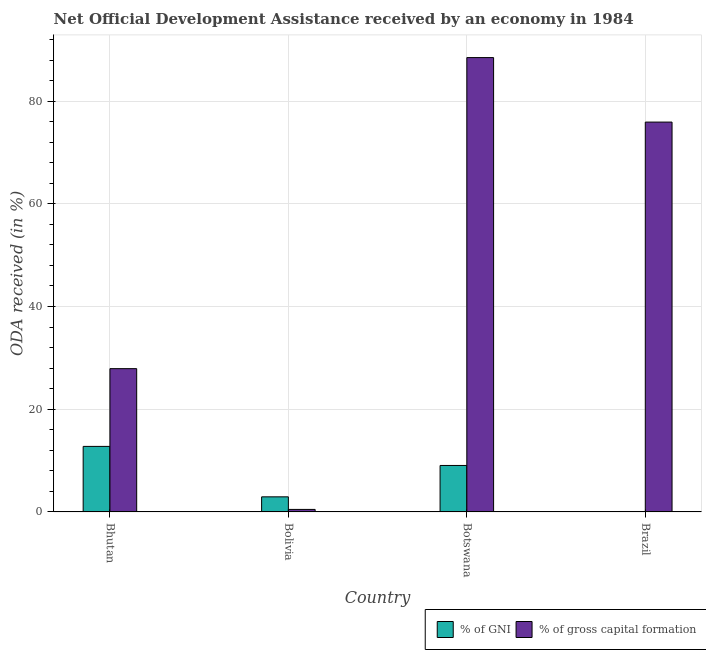How many different coloured bars are there?
Provide a short and direct response. 2. Are the number of bars on each tick of the X-axis equal?
Provide a short and direct response. Yes. How many bars are there on the 4th tick from the left?
Offer a terse response. 2. What is the label of the 3rd group of bars from the left?
Provide a short and direct response. Botswana. What is the oda received as percentage of gross capital formation in Brazil?
Provide a short and direct response. 75.92. Across all countries, what is the maximum oda received as percentage of gni?
Give a very brief answer. 12.76. Across all countries, what is the minimum oda received as percentage of gni?
Make the answer very short. 0.08. In which country was the oda received as percentage of gross capital formation maximum?
Make the answer very short. Botswana. In which country was the oda received as percentage of gni minimum?
Your answer should be compact. Brazil. What is the total oda received as percentage of gross capital formation in the graph?
Ensure brevity in your answer.  192.78. What is the difference between the oda received as percentage of gross capital formation in Bhutan and that in Bolivia?
Offer a terse response. 27.41. What is the difference between the oda received as percentage of gross capital formation in Bolivia and the oda received as percentage of gni in Bhutan?
Your response must be concise. -12.27. What is the average oda received as percentage of gross capital formation per country?
Provide a short and direct response. 48.19. What is the difference between the oda received as percentage of gni and oda received as percentage of gross capital formation in Botswana?
Give a very brief answer. -79.43. What is the ratio of the oda received as percentage of gni in Bolivia to that in Brazil?
Your answer should be compact. 36.09. Is the oda received as percentage of gni in Bhutan less than that in Botswana?
Offer a very short reply. No. Is the difference between the oda received as percentage of gni in Bolivia and Brazil greater than the difference between the oda received as percentage of gross capital formation in Bolivia and Brazil?
Your answer should be very brief. Yes. What is the difference between the highest and the second highest oda received as percentage of gni?
Make the answer very short. 3.71. What is the difference between the highest and the lowest oda received as percentage of gni?
Offer a very short reply. 12.68. Is the sum of the oda received as percentage of gni in Bhutan and Botswana greater than the maximum oda received as percentage of gross capital formation across all countries?
Offer a very short reply. No. What does the 2nd bar from the left in Bolivia represents?
Offer a very short reply. % of gross capital formation. What does the 2nd bar from the right in Botswana represents?
Ensure brevity in your answer.  % of GNI. How many bars are there?
Your response must be concise. 8. Are the values on the major ticks of Y-axis written in scientific E-notation?
Provide a short and direct response. No. Does the graph contain any zero values?
Your response must be concise. No. Where does the legend appear in the graph?
Your answer should be compact. Bottom right. How many legend labels are there?
Provide a short and direct response. 2. How are the legend labels stacked?
Offer a very short reply. Horizontal. What is the title of the graph?
Ensure brevity in your answer.  Net Official Development Assistance received by an economy in 1984. What is the label or title of the X-axis?
Your answer should be very brief. Country. What is the label or title of the Y-axis?
Your answer should be very brief. ODA received (in %). What is the ODA received (in %) of % of GNI in Bhutan?
Offer a very short reply. 12.76. What is the ODA received (in %) in % of gross capital formation in Bhutan?
Offer a terse response. 27.9. What is the ODA received (in %) of % of GNI in Bolivia?
Make the answer very short. 2.93. What is the ODA received (in %) of % of gross capital formation in Bolivia?
Your answer should be compact. 0.49. What is the ODA received (in %) in % of GNI in Botswana?
Ensure brevity in your answer.  9.05. What is the ODA received (in %) in % of gross capital formation in Botswana?
Make the answer very short. 88.47. What is the ODA received (in %) of % of GNI in Brazil?
Your answer should be compact. 0.08. What is the ODA received (in %) in % of gross capital formation in Brazil?
Your response must be concise. 75.92. Across all countries, what is the maximum ODA received (in %) in % of GNI?
Keep it short and to the point. 12.76. Across all countries, what is the maximum ODA received (in %) in % of gross capital formation?
Make the answer very short. 88.47. Across all countries, what is the minimum ODA received (in %) in % of GNI?
Offer a very short reply. 0.08. Across all countries, what is the minimum ODA received (in %) of % of gross capital formation?
Keep it short and to the point. 0.49. What is the total ODA received (in %) of % of GNI in the graph?
Give a very brief answer. 24.82. What is the total ODA received (in %) of % of gross capital formation in the graph?
Ensure brevity in your answer.  192.78. What is the difference between the ODA received (in %) of % of GNI in Bhutan and that in Bolivia?
Provide a short and direct response. 9.82. What is the difference between the ODA received (in %) in % of gross capital formation in Bhutan and that in Bolivia?
Your answer should be very brief. 27.41. What is the difference between the ODA received (in %) of % of GNI in Bhutan and that in Botswana?
Provide a succinct answer. 3.71. What is the difference between the ODA received (in %) in % of gross capital formation in Bhutan and that in Botswana?
Provide a succinct answer. -60.58. What is the difference between the ODA received (in %) of % of GNI in Bhutan and that in Brazil?
Give a very brief answer. 12.68. What is the difference between the ODA received (in %) in % of gross capital formation in Bhutan and that in Brazil?
Offer a very short reply. -48.02. What is the difference between the ODA received (in %) of % of GNI in Bolivia and that in Botswana?
Your answer should be very brief. -6.11. What is the difference between the ODA received (in %) of % of gross capital formation in Bolivia and that in Botswana?
Your response must be concise. -87.99. What is the difference between the ODA received (in %) of % of GNI in Bolivia and that in Brazil?
Keep it short and to the point. 2.85. What is the difference between the ODA received (in %) of % of gross capital formation in Bolivia and that in Brazil?
Provide a short and direct response. -75.43. What is the difference between the ODA received (in %) in % of GNI in Botswana and that in Brazil?
Provide a succinct answer. 8.96. What is the difference between the ODA received (in %) in % of gross capital formation in Botswana and that in Brazil?
Give a very brief answer. 12.56. What is the difference between the ODA received (in %) of % of GNI in Bhutan and the ODA received (in %) of % of gross capital formation in Bolivia?
Make the answer very short. 12.27. What is the difference between the ODA received (in %) of % of GNI in Bhutan and the ODA received (in %) of % of gross capital formation in Botswana?
Give a very brief answer. -75.72. What is the difference between the ODA received (in %) of % of GNI in Bhutan and the ODA received (in %) of % of gross capital formation in Brazil?
Your answer should be very brief. -63.16. What is the difference between the ODA received (in %) in % of GNI in Bolivia and the ODA received (in %) in % of gross capital formation in Botswana?
Your response must be concise. -85.54. What is the difference between the ODA received (in %) in % of GNI in Bolivia and the ODA received (in %) in % of gross capital formation in Brazil?
Ensure brevity in your answer.  -72.98. What is the difference between the ODA received (in %) in % of GNI in Botswana and the ODA received (in %) in % of gross capital formation in Brazil?
Your answer should be very brief. -66.87. What is the average ODA received (in %) of % of GNI per country?
Your response must be concise. 6.21. What is the average ODA received (in %) in % of gross capital formation per country?
Offer a very short reply. 48.19. What is the difference between the ODA received (in %) of % of GNI and ODA received (in %) of % of gross capital formation in Bhutan?
Your answer should be compact. -15.14. What is the difference between the ODA received (in %) in % of GNI and ODA received (in %) in % of gross capital formation in Bolivia?
Provide a succinct answer. 2.45. What is the difference between the ODA received (in %) in % of GNI and ODA received (in %) in % of gross capital formation in Botswana?
Provide a short and direct response. -79.43. What is the difference between the ODA received (in %) in % of GNI and ODA received (in %) in % of gross capital formation in Brazil?
Keep it short and to the point. -75.83. What is the ratio of the ODA received (in %) of % of GNI in Bhutan to that in Bolivia?
Provide a succinct answer. 4.35. What is the ratio of the ODA received (in %) in % of gross capital formation in Bhutan to that in Bolivia?
Provide a short and direct response. 57.27. What is the ratio of the ODA received (in %) of % of GNI in Bhutan to that in Botswana?
Your response must be concise. 1.41. What is the ratio of the ODA received (in %) of % of gross capital formation in Bhutan to that in Botswana?
Your answer should be very brief. 0.32. What is the ratio of the ODA received (in %) of % of GNI in Bhutan to that in Brazil?
Offer a terse response. 156.93. What is the ratio of the ODA received (in %) of % of gross capital formation in Bhutan to that in Brazil?
Offer a terse response. 0.37. What is the ratio of the ODA received (in %) of % of GNI in Bolivia to that in Botswana?
Provide a short and direct response. 0.32. What is the ratio of the ODA received (in %) of % of gross capital formation in Bolivia to that in Botswana?
Your answer should be very brief. 0.01. What is the ratio of the ODA received (in %) of % of GNI in Bolivia to that in Brazil?
Give a very brief answer. 36.09. What is the ratio of the ODA received (in %) of % of gross capital formation in Bolivia to that in Brazil?
Your answer should be very brief. 0.01. What is the ratio of the ODA received (in %) of % of GNI in Botswana to that in Brazil?
Ensure brevity in your answer.  111.27. What is the ratio of the ODA received (in %) of % of gross capital formation in Botswana to that in Brazil?
Give a very brief answer. 1.17. What is the difference between the highest and the second highest ODA received (in %) of % of GNI?
Ensure brevity in your answer.  3.71. What is the difference between the highest and the second highest ODA received (in %) in % of gross capital formation?
Ensure brevity in your answer.  12.56. What is the difference between the highest and the lowest ODA received (in %) of % of GNI?
Give a very brief answer. 12.68. What is the difference between the highest and the lowest ODA received (in %) in % of gross capital formation?
Keep it short and to the point. 87.99. 